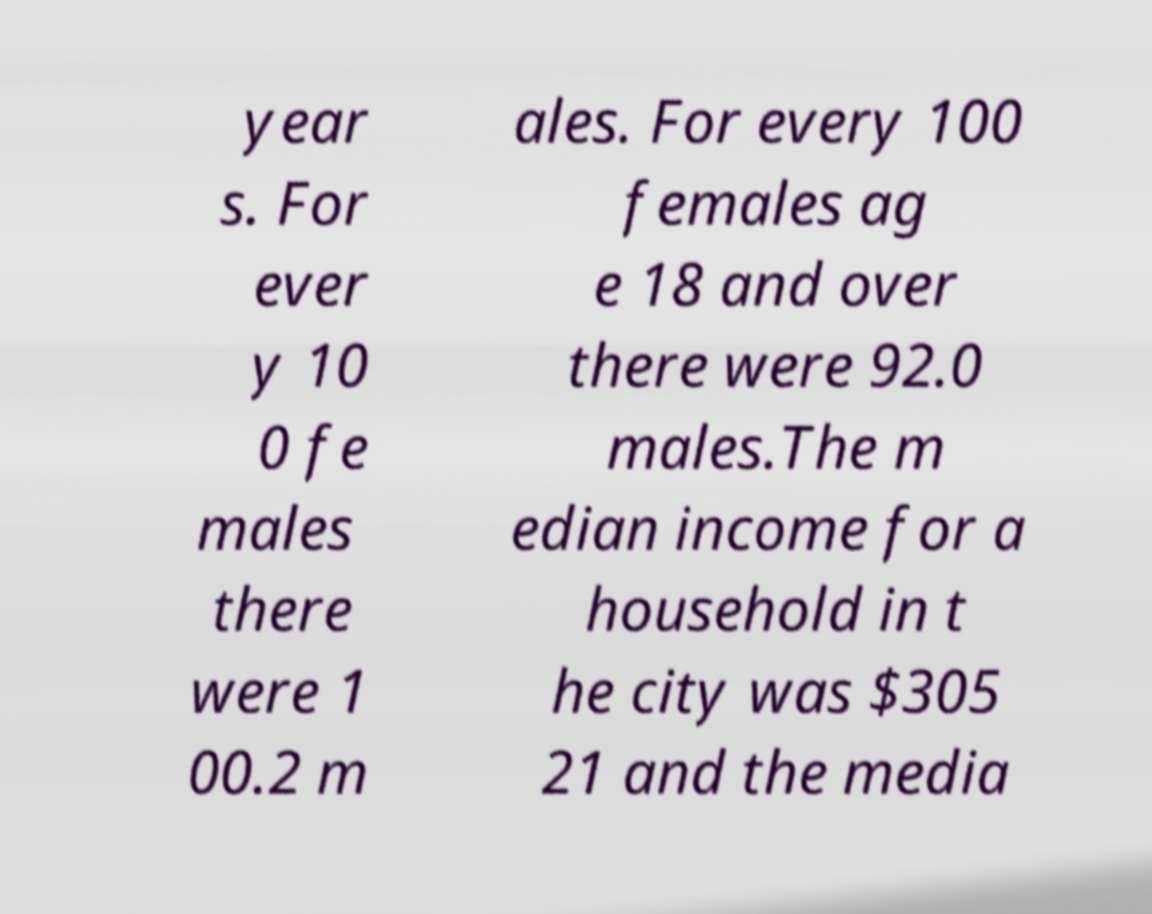Could you assist in decoding the text presented in this image and type it out clearly? year s. For ever y 10 0 fe males there were 1 00.2 m ales. For every 100 females ag e 18 and over there were 92.0 males.The m edian income for a household in t he city was $305 21 and the media 